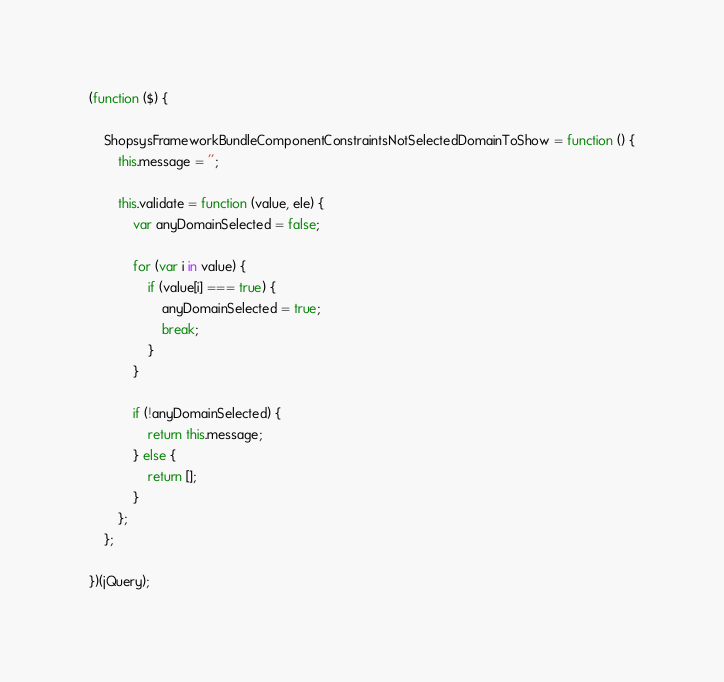<code> <loc_0><loc_0><loc_500><loc_500><_JavaScript_>(function ($) {

    ShopsysFrameworkBundleComponentConstraintsNotSelectedDomainToShow = function () {
        this.message = '';

        this.validate = function (value, ele) {
            var anyDomainSelected = false;

            for (var i in value) {
                if (value[i] === true) {
                    anyDomainSelected = true;
                    break;
                }
            }

            if (!anyDomainSelected) {
                return this.message;
            } else {
                return [];
            }
        };
    };

})(jQuery);
</code> 